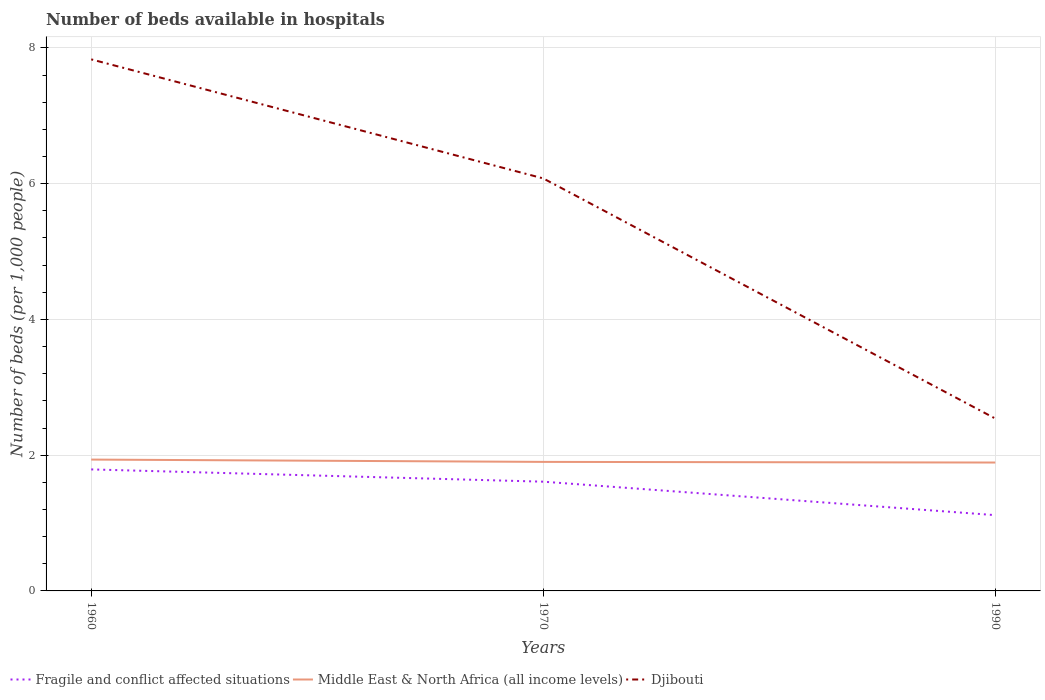Is the number of lines equal to the number of legend labels?
Offer a terse response. Yes. Across all years, what is the maximum number of beds in the hospiatls of in Fragile and conflict affected situations?
Offer a very short reply. 1.12. What is the total number of beds in the hospiatls of in Fragile and conflict affected situations in the graph?
Offer a terse response. 0.67. What is the difference between the highest and the second highest number of beds in the hospiatls of in Middle East & North Africa (all income levels)?
Provide a short and direct response. 0.04. What is the difference between the highest and the lowest number of beds in the hospiatls of in Middle East & North Africa (all income levels)?
Offer a very short reply. 1. How many lines are there?
Your response must be concise. 3. Does the graph contain grids?
Provide a short and direct response. Yes. Where does the legend appear in the graph?
Your response must be concise. Bottom left. How are the legend labels stacked?
Provide a succinct answer. Horizontal. What is the title of the graph?
Ensure brevity in your answer.  Number of beds available in hospitals. What is the label or title of the X-axis?
Your answer should be very brief. Years. What is the label or title of the Y-axis?
Provide a succinct answer. Number of beds (per 1,0 people). What is the Number of beds (per 1,000 people) in Fragile and conflict affected situations in 1960?
Your answer should be very brief. 1.79. What is the Number of beds (per 1,000 people) of Middle East & North Africa (all income levels) in 1960?
Your answer should be compact. 1.94. What is the Number of beds (per 1,000 people) of Djibouti in 1960?
Make the answer very short. 7.83. What is the Number of beds (per 1,000 people) of Fragile and conflict affected situations in 1970?
Keep it short and to the point. 1.61. What is the Number of beds (per 1,000 people) in Middle East & North Africa (all income levels) in 1970?
Provide a short and direct response. 1.9. What is the Number of beds (per 1,000 people) of Djibouti in 1970?
Your answer should be compact. 6.08. What is the Number of beds (per 1,000 people) of Fragile and conflict affected situations in 1990?
Make the answer very short. 1.12. What is the Number of beds (per 1,000 people) in Middle East & North Africa (all income levels) in 1990?
Ensure brevity in your answer.  1.89. What is the Number of beds (per 1,000 people) of Djibouti in 1990?
Provide a succinct answer. 2.54. Across all years, what is the maximum Number of beds (per 1,000 people) in Fragile and conflict affected situations?
Your response must be concise. 1.79. Across all years, what is the maximum Number of beds (per 1,000 people) of Middle East & North Africa (all income levels)?
Offer a terse response. 1.94. Across all years, what is the maximum Number of beds (per 1,000 people) of Djibouti?
Give a very brief answer. 7.83. Across all years, what is the minimum Number of beds (per 1,000 people) in Fragile and conflict affected situations?
Keep it short and to the point. 1.12. Across all years, what is the minimum Number of beds (per 1,000 people) in Middle East & North Africa (all income levels)?
Your answer should be compact. 1.89. Across all years, what is the minimum Number of beds (per 1,000 people) in Djibouti?
Ensure brevity in your answer.  2.54. What is the total Number of beds (per 1,000 people) of Fragile and conflict affected situations in the graph?
Provide a succinct answer. 4.52. What is the total Number of beds (per 1,000 people) in Middle East & North Africa (all income levels) in the graph?
Make the answer very short. 5.73. What is the total Number of beds (per 1,000 people) of Djibouti in the graph?
Your answer should be compact. 16.45. What is the difference between the Number of beds (per 1,000 people) in Fragile and conflict affected situations in 1960 and that in 1970?
Ensure brevity in your answer.  0.18. What is the difference between the Number of beds (per 1,000 people) of Middle East & North Africa (all income levels) in 1960 and that in 1970?
Provide a succinct answer. 0.03. What is the difference between the Number of beds (per 1,000 people) in Djibouti in 1960 and that in 1970?
Give a very brief answer. 1.75. What is the difference between the Number of beds (per 1,000 people) in Fragile and conflict affected situations in 1960 and that in 1990?
Provide a succinct answer. 0.67. What is the difference between the Number of beds (per 1,000 people) in Middle East & North Africa (all income levels) in 1960 and that in 1990?
Ensure brevity in your answer.  0.04. What is the difference between the Number of beds (per 1,000 people) in Djibouti in 1960 and that in 1990?
Make the answer very short. 5.29. What is the difference between the Number of beds (per 1,000 people) in Fragile and conflict affected situations in 1970 and that in 1990?
Your response must be concise. 0.49. What is the difference between the Number of beds (per 1,000 people) of Middle East & North Africa (all income levels) in 1970 and that in 1990?
Offer a very short reply. 0.01. What is the difference between the Number of beds (per 1,000 people) of Djibouti in 1970 and that in 1990?
Give a very brief answer. 3.54. What is the difference between the Number of beds (per 1,000 people) in Fragile and conflict affected situations in 1960 and the Number of beds (per 1,000 people) in Middle East & North Africa (all income levels) in 1970?
Ensure brevity in your answer.  -0.11. What is the difference between the Number of beds (per 1,000 people) in Fragile and conflict affected situations in 1960 and the Number of beds (per 1,000 people) in Djibouti in 1970?
Ensure brevity in your answer.  -4.29. What is the difference between the Number of beds (per 1,000 people) in Middle East & North Africa (all income levels) in 1960 and the Number of beds (per 1,000 people) in Djibouti in 1970?
Your answer should be compact. -4.14. What is the difference between the Number of beds (per 1,000 people) of Fragile and conflict affected situations in 1960 and the Number of beds (per 1,000 people) of Middle East & North Africa (all income levels) in 1990?
Your answer should be compact. -0.1. What is the difference between the Number of beds (per 1,000 people) of Fragile and conflict affected situations in 1960 and the Number of beds (per 1,000 people) of Djibouti in 1990?
Ensure brevity in your answer.  -0.75. What is the difference between the Number of beds (per 1,000 people) in Middle East & North Africa (all income levels) in 1960 and the Number of beds (per 1,000 people) in Djibouti in 1990?
Ensure brevity in your answer.  -0.6. What is the difference between the Number of beds (per 1,000 people) of Fragile and conflict affected situations in 1970 and the Number of beds (per 1,000 people) of Middle East & North Africa (all income levels) in 1990?
Keep it short and to the point. -0.28. What is the difference between the Number of beds (per 1,000 people) of Fragile and conflict affected situations in 1970 and the Number of beds (per 1,000 people) of Djibouti in 1990?
Provide a short and direct response. -0.93. What is the difference between the Number of beds (per 1,000 people) in Middle East & North Africa (all income levels) in 1970 and the Number of beds (per 1,000 people) in Djibouti in 1990?
Your answer should be compact. -0.64. What is the average Number of beds (per 1,000 people) of Fragile and conflict affected situations per year?
Ensure brevity in your answer.  1.51. What is the average Number of beds (per 1,000 people) of Middle East & North Africa (all income levels) per year?
Give a very brief answer. 1.91. What is the average Number of beds (per 1,000 people) in Djibouti per year?
Your answer should be very brief. 5.48. In the year 1960, what is the difference between the Number of beds (per 1,000 people) of Fragile and conflict affected situations and Number of beds (per 1,000 people) of Middle East & North Africa (all income levels)?
Provide a succinct answer. -0.14. In the year 1960, what is the difference between the Number of beds (per 1,000 people) in Fragile and conflict affected situations and Number of beds (per 1,000 people) in Djibouti?
Your answer should be compact. -6.04. In the year 1960, what is the difference between the Number of beds (per 1,000 people) of Middle East & North Africa (all income levels) and Number of beds (per 1,000 people) of Djibouti?
Ensure brevity in your answer.  -5.9. In the year 1970, what is the difference between the Number of beds (per 1,000 people) in Fragile and conflict affected situations and Number of beds (per 1,000 people) in Middle East & North Africa (all income levels)?
Give a very brief answer. -0.29. In the year 1970, what is the difference between the Number of beds (per 1,000 people) of Fragile and conflict affected situations and Number of beds (per 1,000 people) of Djibouti?
Ensure brevity in your answer.  -4.47. In the year 1970, what is the difference between the Number of beds (per 1,000 people) of Middle East & North Africa (all income levels) and Number of beds (per 1,000 people) of Djibouti?
Keep it short and to the point. -4.18. In the year 1990, what is the difference between the Number of beds (per 1,000 people) of Fragile and conflict affected situations and Number of beds (per 1,000 people) of Middle East & North Africa (all income levels)?
Provide a short and direct response. -0.78. In the year 1990, what is the difference between the Number of beds (per 1,000 people) in Fragile and conflict affected situations and Number of beds (per 1,000 people) in Djibouti?
Offer a very short reply. -1.42. In the year 1990, what is the difference between the Number of beds (per 1,000 people) of Middle East & North Africa (all income levels) and Number of beds (per 1,000 people) of Djibouti?
Offer a terse response. -0.65. What is the ratio of the Number of beds (per 1,000 people) of Fragile and conflict affected situations in 1960 to that in 1970?
Ensure brevity in your answer.  1.11. What is the ratio of the Number of beds (per 1,000 people) of Middle East & North Africa (all income levels) in 1960 to that in 1970?
Offer a terse response. 1.02. What is the ratio of the Number of beds (per 1,000 people) of Djibouti in 1960 to that in 1970?
Provide a succinct answer. 1.29. What is the ratio of the Number of beds (per 1,000 people) in Fragile and conflict affected situations in 1960 to that in 1990?
Make the answer very short. 1.6. What is the ratio of the Number of beds (per 1,000 people) of Djibouti in 1960 to that in 1990?
Your answer should be compact. 3.08. What is the ratio of the Number of beds (per 1,000 people) of Fragile and conflict affected situations in 1970 to that in 1990?
Make the answer very short. 1.44. What is the ratio of the Number of beds (per 1,000 people) in Middle East & North Africa (all income levels) in 1970 to that in 1990?
Your answer should be compact. 1. What is the ratio of the Number of beds (per 1,000 people) in Djibouti in 1970 to that in 1990?
Ensure brevity in your answer.  2.39. What is the difference between the highest and the second highest Number of beds (per 1,000 people) in Fragile and conflict affected situations?
Your response must be concise. 0.18. What is the difference between the highest and the second highest Number of beds (per 1,000 people) in Middle East & North Africa (all income levels)?
Make the answer very short. 0.03. What is the difference between the highest and the second highest Number of beds (per 1,000 people) of Djibouti?
Offer a terse response. 1.75. What is the difference between the highest and the lowest Number of beds (per 1,000 people) in Fragile and conflict affected situations?
Ensure brevity in your answer.  0.67. What is the difference between the highest and the lowest Number of beds (per 1,000 people) in Middle East & North Africa (all income levels)?
Keep it short and to the point. 0.04. What is the difference between the highest and the lowest Number of beds (per 1,000 people) of Djibouti?
Your answer should be compact. 5.29. 